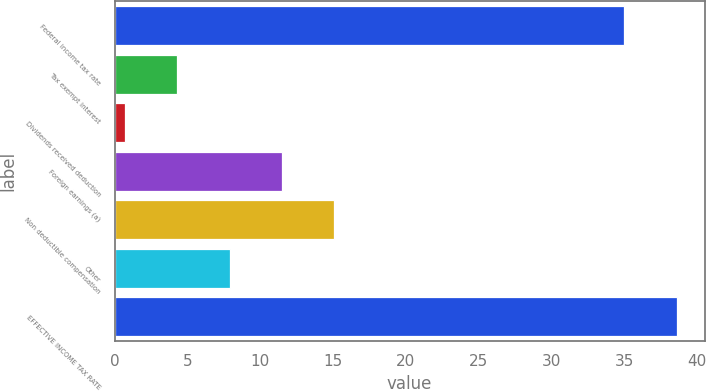Convert chart. <chart><loc_0><loc_0><loc_500><loc_500><bar_chart><fcel>Federal income tax rate<fcel>Tax exempt interest<fcel>Dividends received deduction<fcel>Foreign earnings (a)<fcel>Non deductible compensation<fcel>Other<fcel>EFFECTIVE INCOME TAX RATE<nl><fcel>35<fcel>4.3<fcel>0.7<fcel>11.5<fcel>15.1<fcel>7.9<fcel>38.6<nl></chart> 